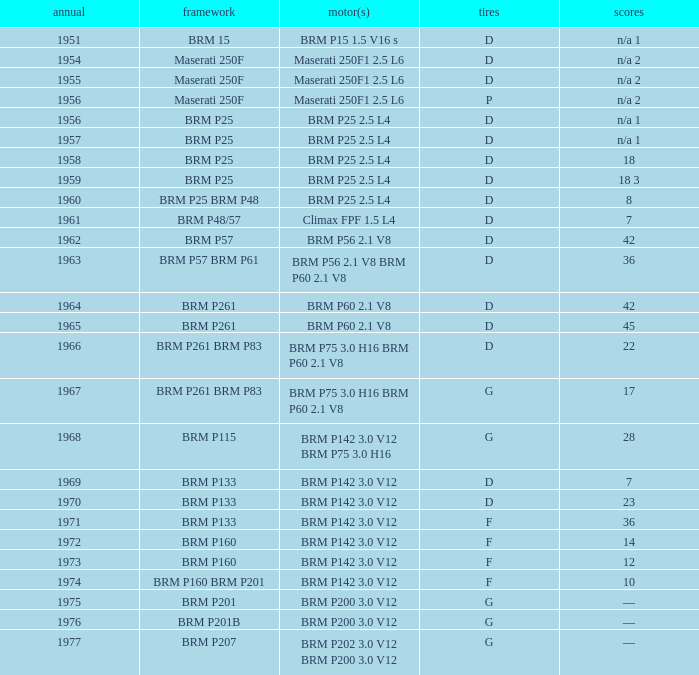Name the sum of year for engine of brm p202 3.0 v12 brm p200 3.0 v12 1977.0. 